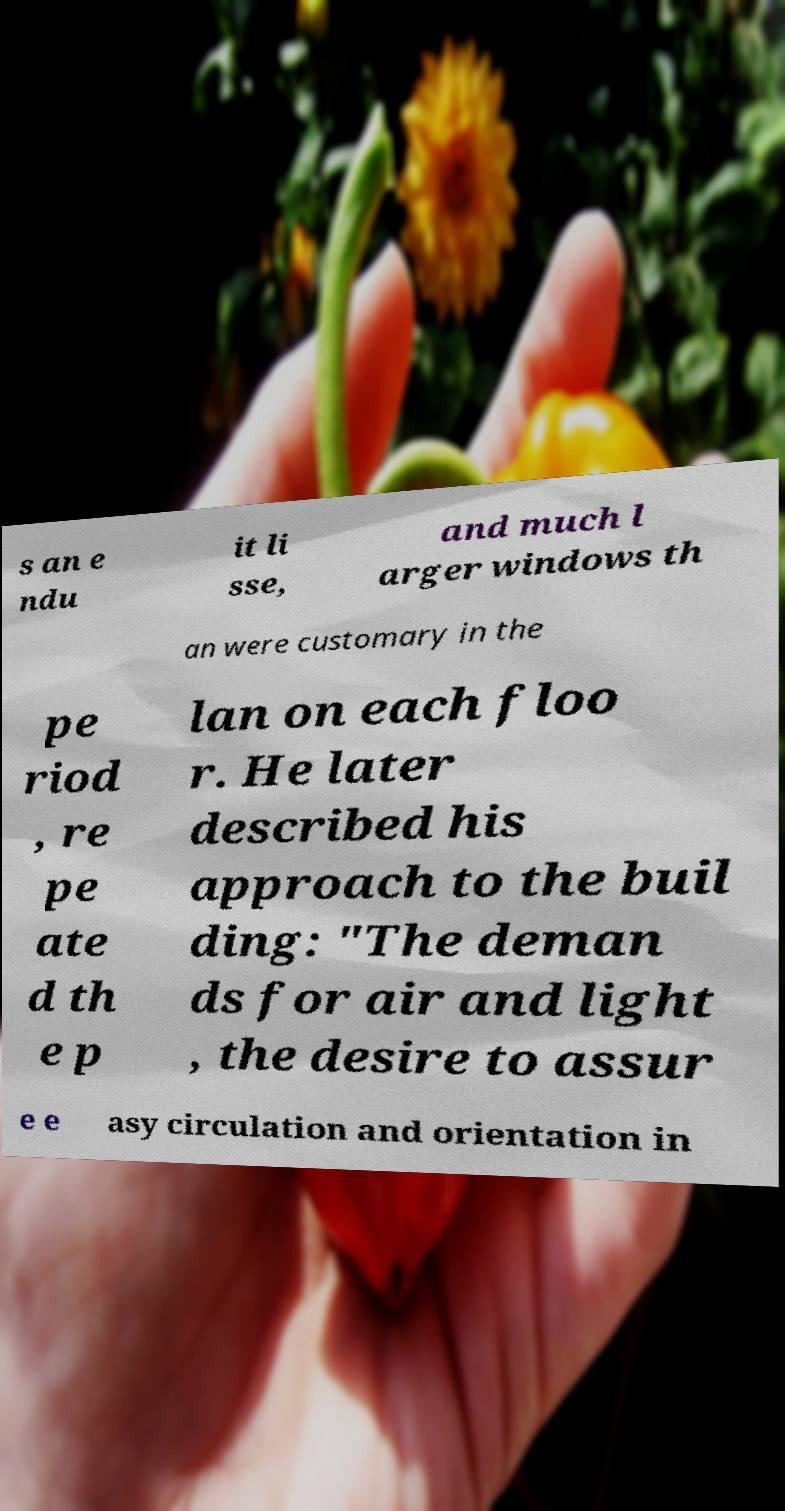Please read and relay the text visible in this image. What does it say? s an e ndu it li sse, and much l arger windows th an were customary in the pe riod , re pe ate d th e p lan on each floo r. He later described his approach to the buil ding: "The deman ds for air and light , the desire to assur e e asy circulation and orientation in 